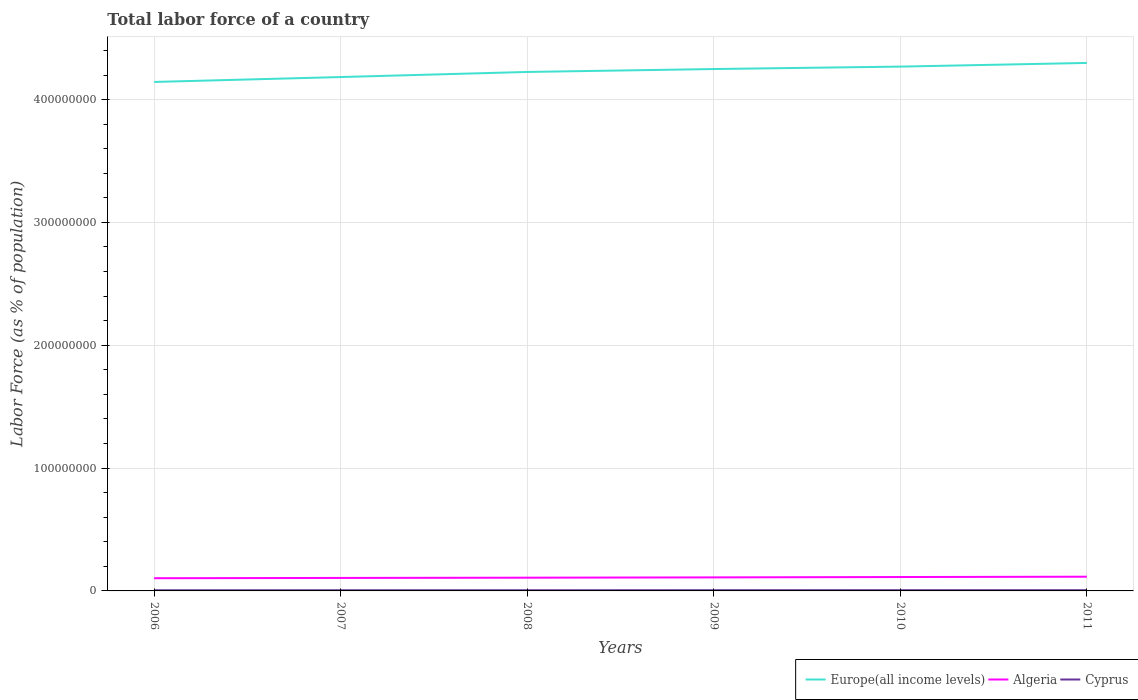How many different coloured lines are there?
Make the answer very short. 3. Is the number of lines equal to the number of legend labels?
Offer a terse response. Yes. Across all years, what is the maximum percentage of labor force in Cyprus?
Ensure brevity in your answer.  5.37e+05. In which year was the percentage of labor force in Europe(all income levels) maximum?
Offer a terse response. 2006. What is the total percentage of labor force in Algeria in the graph?
Give a very brief answer. -2.43e+05. What is the difference between the highest and the second highest percentage of labor force in Cyprus?
Your answer should be very brief. 4.87e+04. What is the difference between the highest and the lowest percentage of labor force in Algeria?
Make the answer very short. 3. Is the percentage of labor force in Europe(all income levels) strictly greater than the percentage of labor force in Cyprus over the years?
Your answer should be very brief. No. How many lines are there?
Offer a very short reply. 3. What is the difference between two consecutive major ticks on the Y-axis?
Make the answer very short. 1.00e+08. Are the values on the major ticks of Y-axis written in scientific E-notation?
Your answer should be very brief. No. Does the graph contain any zero values?
Your answer should be very brief. No. Does the graph contain grids?
Make the answer very short. Yes. How many legend labels are there?
Provide a succinct answer. 3. How are the legend labels stacked?
Your response must be concise. Horizontal. What is the title of the graph?
Ensure brevity in your answer.  Total labor force of a country. What is the label or title of the Y-axis?
Offer a terse response. Labor Force (as % of population). What is the Labor Force (as % of population) in Europe(all income levels) in 2006?
Your answer should be compact. 4.14e+08. What is the Labor Force (as % of population) in Algeria in 2006?
Keep it short and to the point. 1.03e+07. What is the Labor Force (as % of population) in Cyprus in 2006?
Offer a very short reply. 5.37e+05. What is the Labor Force (as % of population) in Europe(all income levels) in 2007?
Your answer should be very brief. 4.18e+08. What is the Labor Force (as % of population) of Algeria in 2007?
Offer a very short reply. 1.06e+07. What is the Labor Force (as % of population) of Cyprus in 2007?
Ensure brevity in your answer.  5.50e+05. What is the Labor Force (as % of population) of Europe(all income levels) in 2008?
Make the answer very short. 4.22e+08. What is the Labor Force (as % of population) in Algeria in 2008?
Provide a short and direct response. 1.08e+07. What is the Labor Force (as % of population) of Cyprus in 2008?
Give a very brief answer. 5.60e+05. What is the Labor Force (as % of population) of Europe(all income levels) in 2009?
Provide a succinct answer. 4.25e+08. What is the Labor Force (as % of population) in Algeria in 2009?
Make the answer very short. 1.10e+07. What is the Labor Force (as % of population) of Cyprus in 2009?
Give a very brief answer. 5.71e+05. What is the Labor Force (as % of population) of Europe(all income levels) in 2010?
Your response must be concise. 4.27e+08. What is the Labor Force (as % of population) in Algeria in 2010?
Offer a very short reply. 1.13e+07. What is the Labor Force (as % of population) of Cyprus in 2010?
Provide a succinct answer. 5.84e+05. What is the Labor Force (as % of population) of Europe(all income levels) in 2011?
Provide a short and direct response. 4.30e+08. What is the Labor Force (as % of population) in Algeria in 2011?
Your answer should be very brief. 1.16e+07. What is the Labor Force (as % of population) in Cyprus in 2011?
Your response must be concise. 5.86e+05. Across all years, what is the maximum Labor Force (as % of population) of Europe(all income levels)?
Give a very brief answer. 4.30e+08. Across all years, what is the maximum Labor Force (as % of population) in Algeria?
Provide a succinct answer. 1.16e+07. Across all years, what is the maximum Labor Force (as % of population) of Cyprus?
Your answer should be compact. 5.86e+05. Across all years, what is the minimum Labor Force (as % of population) in Europe(all income levels)?
Ensure brevity in your answer.  4.14e+08. Across all years, what is the minimum Labor Force (as % of population) of Algeria?
Provide a short and direct response. 1.03e+07. Across all years, what is the minimum Labor Force (as % of population) of Cyprus?
Your answer should be very brief. 5.37e+05. What is the total Labor Force (as % of population) of Europe(all income levels) in the graph?
Your response must be concise. 2.54e+09. What is the total Labor Force (as % of population) in Algeria in the graph?
Give a very brief answer. 6.56e+07. What is the total Labor Force (as % of population) in Cyprus in the graph?
Your answer should be very brief. 3.39e+06. What is the difference between the Labor Force (as % of population) in Europe(all income levels) in 2006 and that in 2007?
Keep it short and to the point. -3.99e+06. What is the difference between the Labor Force (as % of population) in Algeria in 2006 and that in 2007?
Keep it short and to the point. -2.33e+05. What is the difference between the Labor Force (as % of population) of Cyprus in 2006 and that in 2007?
Offer a very short reply. -1.30e+04. What is the difference between the Labor Force (as % of population) in Europe(all income levels) in 2006 and that in 2008?
Your response must be concise. -8.14e+06. What is the difference between the Labor Force (as % of population) in Algeria in 2006 and that in 2008?
Keep it short and to the point. -4.32e+05. What is the difference between the Labor Force (as % of population) of Cyprus in 2006 and that in 2008?
Offer a terse response. -2.25e+04. What is the difference between the Labor Force (as % of population) in Europe(all income levels) in 2006 and that in 2009?
Your response must be concise. -1.05e+07. What is the difference between the Labor Force (as % of population) of Algeria in 2006 and that in 2009?
Offer a terse response. -6.75e+05. What is the difference between the Labor Force (as % of population) in Cyprus in 2006 and that in 2009?
Provide a succinct answer. -3.36e+04. What is the difference between the Labor Force (as % of population) of Europe(all income levels) in 2006 and that in 2010?
Make the answer very short. -1.25e+07. What is the difference between the Labor Force (as % of population) of Algeria in 2006 and that in 2010?
Keep it short and to the point. -9.66e+05. What is the difference between the Labor Force (as % of population) in Cyprus in 2006 and that in 2010?
Make the answer very short. -4.73e+04. What is the difference between the Labor Force (as % of population) in Europe(all income levels) in 2006 and that in 2011?
Offer a very short reply. -1.55e+07. What is the difference between the Labor Force (as % of population) of Algeria in 2006 and that in 2011?
Offer a terse response. -1.23e+06. What is the difference between the Labor Force (as % of population) of Cyprus in 2006 and that in 2011?
Provide a succinct answer. -4.87e+04. What is the difference between the Labor Force (as % of population) of Europe(all income levels) in 2007 and that in 2008?
Offer a very short reply. -4.15e+06. What is the difference between the Labor Force (as % of population) of Algeria in 2007 and that in 2008?
Keep it short and to the point. -1.99e+05. What is the difference between the Labor Force (as % of population) in Cyprus in 2007 and that in 2008?
Provide a short and direct response. -9460. What is the difference between the Labor Force (as % of population) of Europe(all income levels) in 2007 and that in 2009?
Your answer should be very brief. -6.53e+06. What is the difference between the Labor Force (as % of population) of Algeria in 2007 and that in 2009?
Offer a very short reply. -4.42e+05. What is the difference between the Labor Force (as % of population) in Cyprus in 2007 and that in 2009?
Your response must be concise. -2.06e+04. What is the difference between the Labor Force (as % of population) in Europe(all income levels) in 2007 and that in 2010?
Your answer should be very brief. -8.50e+06. What is the difference between the Labor Force (as % of population) in Algeria in 2007 and that in 2010?
Make the answer very short. -7.33e+05. What is the difference between the Labor Force (as % of population) in Cyprus in 2007 and that in 2010?
Offer a very short reply. -3.43e+04. What is the difference between the Labor Force (as % of population) of Europe(all income levels) in 2007 and that in 2011?
Provide a succinct answer. -1.15e+07. What is the difference between the Labor Force (as % of population) of Algeria in 2007 and that in 2011?
Offer a very short reply. -9.94e+05. What is the difference between the Labor Force (as % of population) in Cyprus in 2007 and that in 2011?
Your answer should be very brief. -3.57e+04. What is the difference between the Labor Force (as % of population) of Europe(all income levels) in 2008 and that in 2009?
Offer a very short reply. -2.38e+06. What is the difference between the Labor Force (as % of population) in Algeria in 2008 and that in 2009?
Give a very brief answer. -2.43e+05. What is the difference between the Labor Force (as % of population) in Cyprus in 2008 and that in 2009?
Your answer should be very brief. -1.11e+04. What is the difference between the Labor Force (as % of population) of Europe(all income levels) in 2008 and that in 2010?
Give a very brief answer. -4.35e+06. What is the difference between the Labor Force (as % of population) of Algeria in 2008 and that in 2010?
Give a very brief answer. -5.34e+05. What is the difference between the Labor Force (as % of population) of Cyprus in 2008 and that in 2010?
Offer a terse response. -2.48e+04. What is the difference between the Labor Force (as % of population) of Europe(all income levels) in 2008 and that in 2011?
Your answer should be very brief. -7.33e+06. What is the difference between the Labor Force (as % of population) in Algeria in 2008 and that in 2011?
Give a very brief answer. -7.95e+05. What is the difference between the Labor Force (as % of population) of Cyprus in 2008 and that in 2011?
Ensure brevity in your answer.  -2.62e+04. What is the difference between the Labor Force (as % of population) in Europe(all income levels) in 2009 and that in 2010?
Offer a very short reply. -1.97e+06. What is the difference between the Labor Force (as % of population) in Algeria in 2009 and that in 2010?
Offer a very short reply. -2.91e+05. What is the difference between the Labor Force (as % of population) of Cyprus in 2009 and that in 2010?
Keep it short and to the point. -1.37e+04. What is the difference between the Labor Force (as % of population) of Europe(all income levels) in 2009 and that in 2011?
Provide a succinct answer. -4.95e+06. What is the difference between the Labor Force (as % of population) of Algeria in 2009 and that in 2011?
Provide a short and direct response. -5.52e+05. What is the difference between the Labor Force (as % of population) in Cyprus in 2009 and that in 2011?
Provide a succinct answer. -1.51e+04. What is the difference between the Labor Force (as % of population) of Europe(all income levels) in 2010 and that in 2011?
Provide a succinct answer. -2.99e+06. What is the difference between the Labor Force (as % of population) of Algeria in 2010 and that in 2011?
Provide a succinct answer. -2.61e+05. What is the difference between the Labor Force (as % of population) in Cyprus in 2010 and that in 2011?
Your answer should be compact. -1364. What is the difference between the Labor Force (as % of population) in Europe(all income levels) in 2006 and the Labor Force (as % of population) in Algeria in 2007?
Your answer should be compact. 4.04e+08. What is the difference between the Labor Force (as % of population) of Europe(all income levels) in 2006 and the Labor Force (as % of population) of Cyprus in 2007?
Keep it short and to the point. 4.14e+08. What is the difference between the Labor Force (as % of population) in Algeria in 2006 and the Labor Force (as % of population) in Cyprus in 2007?
Provide a succinct answer. 9.79e+06. What is the difference between the Labor Force (as % of population) of Europe(all income levels) in 2006 and the Labor Force (as % of population) of Algeria in 2008?
Offer a very short reply. 4.04e+08. What is the difference between the Labor Force (as % of population) of Europe(all income levels) in 2006 and the Labor Force (as % of population) of Cyprus in 2008?
Keep it short and to the point. 4.14e+08. What is the difference between the Labor Force (as % of population) in Algeria in 2006 and the Labor Force (as % of population) in Cyprus in 2008?
Provide a short and direct response. 9.78e+06. What is the difference between the Labor Force (as % of population) in Europe(all income levels) in 2006 and the Labor Force (as % of population) in Algeria in 2009?
Your answer should be compact. 4.03e+08. What is the difference between the Labor Force (as % of population) in Europe(all income levels) in 2006 and the Labor Force (as % of population) in Cyprus in 2009?
Offer a very short reply. 4.14e+08. What is the difference between the Labor Force (as % of population) in Algeria in 2006 and the Labor Force (as % of population) in Cyprus in 2009?
Provide a short and direct response. 9.77e+06. What is the difference between the Labor Force (as % of population) of Europe(all income levels) in 2006 and the Labor Force (as % of population) of Algeria in 2010?
Offer a terse response. 4.03e+08. What is the difference between the Labor Force (as % of population) of Europe(all income levels) in 2006 and the Labor Force (as % of population) of Cyprus in 2010?
Offer a very short reply. 4.14e+08. What is the difference between the Labor Force (as % of population) in Algeria in 2006 and the Labor Force (as % of population) in Cyprus in 2010?
Offer a terse response. 9.76e+06. What is the difference between the Labor Force (as % of population) in Europe(all income levels) in 2006 and the Labor Force (as % of population) in Algeria in 2011?
Make the answer very short. 4.03e+08. What is the difference between the Labor Force (as % of population) of Europe(all income levels) in 2006 and the Labor Force (as % of population) of Cyprus in 2011?
Give a very brief answer. 4.14e+08. What is the difference between the Labor Force (as % of population) in Algeria in 2006 and the Labor Force (as % of population) in Cyprus in 2011?
Keep it short and to the point. 9.76e+06. What is the difference between the Labor Force (as % of population) of Europe(all income levels) in 2007 and the Labor Force (as % of population) of Algeria in 2008?
Your answer should be very brief. 4.08e+08. What is the difference between the Labor Force (as % of population) of Europe(all income levels) in 2007 and the Labor Force (as % of population) of Cyprus in 2008?
Offer a terse response. 4.18e+08. What is the difference between the Labor Force (as % of population) in Algeria in 2007 and the Labor Force (as % of population) in Cyprus in 2008?
Your answer should be compact. 1.00e+07. What is the difference between the Labor Force (as % of population) in Europe(all income levels) in 2007 and the Labor Force (as % of population) in Algeria in 2009?
Make the answer very short. 4.07e+08. What is the difference between the Labor Force (as % of population) in Europe(all income levels) in 2007 and the Labor Force (as % of population) in Cyprus in 2009?
Provide a succinct answer. 4.18e+08. What is the difference between the Labor Force (as % of population) of Algeria in 2007 and the Labor Force (as % of population) of Cyprus in 2009?
Provide a succinct answer. 1.00e+07. What is the difference between the Labor Force (as % of population) of Europe(all income levels) in 2007 and the Labor Force (as % of population) of Algeria in 2010?
Offer a very short reply. 4.07e+08. What is the difference between the Labor Force (as % of population) of Europe(all income levels) in 2007 and the Labor Force (as % of population) of Cyprus in 2010?
Provide a succinct answer. 4.18e+08. What is the difference between the Labor Force (as % of population) of Algeria in 2007 and the Labor Force (as % of population) of Cyprus in 2010?
Give a very brief answer. 9.99e+06. What is the difference between the Labor Force (as % of population) in Europe(all income levels) in 2007 and the Labor Force (as % of population) in Algeria in 2011?
Your answer should be very brief. 4.07e+08. What is the difference between the Labor Force (as % of population) of Europe(all income levels) in 2007 and the Labor Force (as % of population) of Cyprus in 2011?
Make the answer very short. 4.18e+08. What is the difference between the Labor Force (as % of population) in Algeria in 2007 and the Labor Force (as % of population) in Cyprus in 2011?
Your response must be concise. 9.99e+06. What is the difference between the Labor Force (as % of population) in Europe(all income levels) in 2008 and the Labor Force (as % of population) in Algeria in 2009?
Ensure brevity in your answer.  4.11e+08. What is the difference between the Labor Force (as % of population) of Europe(all income levels) in 2008 and the Labor Force (as % of population) of Cyprus in 2009?
Provide a short and direct response. 4.22e+08. What is the difference between the Labor Force (as % of population) in Algeria in 2008 and the Labor Force (as % of population) in Cyprus in 2009?
Offer a terse response. 1.02e+07. What is the difference between the Labor Force (as % of population) of Europe(all income levels) in 2008 and the Labor Force (as % of population) of Algeria in 2010?
Offer a terse response. 4.11e+08. What is the difference between the Labor Force (as % of population) of Europe(all income levels) in 2008 and the Labor Force (as % of population) of Cyprus in 2010?
Provide a short and direct response. 4.22e+08. What is the difference between the Labor Force (as % of population) of Algeria in 2008 and the Labor Force (as % of population) of Cyprus in 2010?
Your answer should be very brief. 1.02e+07. What is the difference between the Labor Force (as % of population) of Europe(all income levels) in 2008 and the Labor Force (as % of population) of Algeria in 2011?
Your answer should be compact. 4.11e+08. What is the difference between the Labor Force (as % of population) in Europe(all income levels) in 2008 and the Labor Force (as % of population) in Cyprus in 2011?
Your answer should be compact. 4.22e+08. What is the difference between the Labor Force (as % of population) of Algeria in 2008 and the Labor Force (as % of population) of Cyprus in 2011?
Your answer should be compact. 1.02e+07. What is the difference between the Labor Force (as % of population) in Europe(all income levels) in 2009 and the Labor Force (as % of population) in Algeria in 2010?
Ensure brevity in your answer.  4.14e+08. What is the difference between the Labor Force (as % of population) of Europe(all income levels) in 2009 and the Labor Force (as % of population) of Cyprus in 2010?
Make the answer very short. 4.24e+08. What is the difference between the Labor Force (as % of population) in Algeria in 2009 and the Labor Force (as % of population) in Cyprus in 2010?
Offer a terse response. 1.04e+07. What is the difference between the Labor Force (as % of population) in Europe(all income levels) in 2009 and the Labor Force (as % of population) in Algeria in 2011?
Your answer should be compact. 4.13e+08. What is the difference between the Labor Force (as % of population) of Europe(all income levels) in 2009 and the Labor Force (as % of population) of Cyprus in 2011?
Ensure brevity in your answer.  4.24e+08. What is the difference between the Labor Force (as % of population) of Algeria in 2009 and the Labor Force (as % of population) of Cyprus in 2011?
Your response must be concise. 1.04e+07. What is the difference between the Labor Force (as % of population) of Europe(all income levels) in 2010 and the Labor Force (as % of population) of Algeria in 2011?
Keep it short and to the point. 4.15e+08. What is the difference between the Labor Force (as % of population) in Europe(all income levels) in 2010 and the Labor Force (as % of population) in Cyprus in 2011?
Provide a short and direct response. 4.26e+08. What is the difference between the Labor Force (as % of population) in Algeria in 2010 and the Labor Force (as % of population) in Cyprus in 2011?
Your answer should be very brief. 1.07e+07. What is the average Labor Force (as % of population) in Europe(all income levels) per year?
Offer a terse response. 4.23e+08. What is the average Labor Force (as % of population) in Algeria per year?
Make the answer very short. 1.09e+07. What is the average Labor Force (as % of population) of Cyprus per year?
Provide a succinct answer. 5.65e+05. In the year 2006, what is the difference between the Labor Force (as % of population) of Europe(all income levels) and Labor Force (as % of population) of Algeria?
Your answer should be compact. 4.04e+08. In the year 2006, what is the difference between the Labor Force (as % of population) of Europe(all income levels) and Labor Force (as % of population) of Cyprus?
Make the answer very short. 4.14e+08. In the year 2006, what is the difference between the Labor Force (as % of population) of Algeria and Labor Force (as % of population) of Cyprus?
Ensure brevity in your answer.  9.81e+06. In the year 2007, what is the difference between the Labor Force (as % of population) of Europe(all income levels) and Labor Force (as % of population) of Algeria?
Your answer should be very brief. 4.08e+08. In the year 2007, what is the difference between the Labor Force (as % of population) of Europe(all income levels) and Labor Force (as % of population) of Cyprus?
Offer a very short reply. 4.18e+08. In the year 2007, what is the difference between the Labor Force (as % of population) of Algeria and Labor Force (as % of population) of Cyprus?
Give a very brief answer. 1.00e+07. In the year 2008, what is the difference between the Labor Force (as % of population) in Europe(all income levels) and Labor Force (as % of population) in Algeria?
Ensure brevity in your answer.  4.12e+08. In the year 2008, what is the difference between the Labor Force (as % of population) in Europe(all income levels) and Labor Force (as % of population) in Cyprus?
Provide a succinct answer. 4.22e+08. In the year 2008, what is the difference between the Labor Force (as % of population) of Algeria and Labor Force (as % of population) of Cyprus?
Offer a very short reply. 1.02e+07. In the year 2009, what is the difference between the Labor Force (as % of population) of Europe(all income levels) and Labor Force (as % of population) of Algeria?
Your answer should be very brief. 4.14e+08. In the year 2009, what is the difference between the Labor Force (as % of population) of Europe(all income levels) and Labor Force (as % of population) of Cyprus?
Provide a short and direct response. 4.24e+08. In the year 2009, what is the difference between the Labor Force (as % of population) of Algeria and Labor Force (as % of population) of Cyprus?
Ensure brevity in your answer.  1.04e+07. In the year 2010, what is the difference between the Labor Force (as % of population) of Europe(all income levels) and Labor Force (as % of population) of Algeria?
Provide a short and direct response. 4.16e+08. In the year 2010, what is the difference between the Labor Force (as % of population) in Europe(all income levels) and Labor Force (as % of population) in Cyprus?
Give a very brief answer. 4.26e+08. In the year 2010, what is the difference between the Labor Force (as % of population) of Algeria and Labor Force (as % of population) of Cyprus?
Provide a short and direct response. 1.07e+07. In the year 2011, what is the difference between the Labor Force (as % of population) of Europe(all income levels) and Labor Force (as % of population) of Algeria?
Keep it short and to the point. 4.18e+08. In the year 2011, what is the difference between the Labor Force (as % of population) of Europe(all income levels) and Labor Force (as % of population) of Cyprus?
Give a very brief answer. 4.29e+08. In the year 2011, what is the difference between the Labor Force (as % of population) in Algeria and Labor Force (as % of population) in Cyprus?
Your response must be concise. 1.10e+07. What is the ratio of the Labor Force (as % of population) of Cyprus in 2006 to that in 2007?
Ensure brevity in your answer.  0.98. What is the ratio of the Labor Force (as % of population) of Europe(all income levels) in 2006 to that in 2008?
Your answer should be very brief. 0.98. What is the ratio of the Labor Force (as % of population) of Algeria in 2006 to that in 2008?
Ensure brevity in your answer.  0.96. What is the ratio of the Labor Force (as % of population) in Cyprus in 2006 to that in 2008?
Provide a short and direct response. 0.96. What is the ratio of the Labor Force (as % of population) in Europe(all income levels) in 2006 to that in 2009?
Your answer should be very brief. 0.98. What is the ratio of the Labor Force (as % of population) of Algeria in 2006 to that in 2009?
Offer a terse response. 0.94. What is the ratio of the Labor Force (as % of population) in Cyprus in 2006 to that in 2009?
Give a very brief answer. 0.94. What is the ratio of the Labor Force (as % of population) in Europe(all income levels) in 2006 to that in 2010?
Your answer should be very brief. 0.97. What is the ratio of the Labor Force (as % of population) of Algeria in 2006 to that in 2010?
Keep it short and to the point. 0.91. What is the ratio of the Labor Force (as % of population) of Cyprus in 2006 to that in 2010?
Your answer should be compact. 0.92. What is the ratio of the Labor Force (as % of population) in Europe(all income levels) in 2006 to that in 2011?
Offer a very short reply. 0.96. What is the ratio of the Labor Force (as % of population) in Algeria in 2006 to that in 2011?
Ensure brevity in your answer.  0.89. What is the ratio of the Labor Force (as % of population) of Cyprus in 2006 to that in 2011?
Offer a terse response. 0.92. What is the ratio of the Labor Force (as % of population) in Europe(all income levels) in 2007 to that in 2008?
Keep it short and to the point. 0.99. What is the ratio of the Labor Force (as % of population) in Algeria in 2007 to that in 2008?
Provide a succinct answer. 0.98. What is the ratio of the Labor Force (as % of population) in Cyprus in 2007 to that in 2008?
Ensure brevity in your answer.  0.98. What is the ratio of the Labor Force (as % of population) of Europe(all income levels) in 2007 to that in 2009?
Your answer should be compact. 0.98. What is the ratio of the Labor Force (as % of population) of Algeria in 2007 to that in 2009?
Ensure brevity in your answer.  0.96. What is the ratio of the Labor Force (as % of population) of Europe(all income levels) in 2007 to that in 2010?
Offer a very short reply. 0.98. What is the ratio of the Labor Force (as % of population) in Algeria in 2007 to that in 2010?
Your answer should be very brief. 0.94. What is the ratio of the Labor Force (as % of population) in Cyprus in 2007 to that in 2010?
Offer a terse response. 0.94. What is the ratio of the Labor Force (as % of population) in Europe(all income levels) in 2007 to that in 2011?
Offer a very short reply. 0.97. What is the ratio of the Labor Force (as % of population) in Algeria in 2007 to that in 2011?
Give a very brief answer. 0.91. What is the ratio of the Labor Force (as % of population) of Cyprus in 2007 to that in 2011?
Keep it short and to the point. 0.94. What is the ratio of the Labor Force (as % of population) of Algeria in 2008 to that in 2009?
Offer a very short reply. 0.98. What is the ratio of the Labor Force (as % of population) in Cyprus in 2008 to that in 2009?
Ensure brevity in your answer.  0.98. What is the ratio of the Labor Force (as % of population) in Europe(all income levels) in 2008 to that in 2010?
Provide a short and direct response. 0.99. What is the ratio of the Labor Force (as % of population) of Algeria in 2008 to that in 2010?
Make the answer very short. 0.95. What is the ratio of the Labor Force (as % of population) of Cyprus in 2008 to that in 2010?
Make the answer very short. 0.96. What is the ratio of the Labor Force (as % of population) of Europe(all income levels) in 2008 to that in 2011?
Your answer should be compact. 0.98. What is the ratio of the Labor Force (as % of population) of Algeria in 2008 to that in 2011?
Give a very brief answer. 0.93. What is the ratio of the Labor Force (as % of population) in Cyprus in 2008 to that in 2011?
Offer a terse response. 0.96. What is the ratio of the Labor Force (as % of population) in Europe(all income levels) in 2009 to that in 2010?
Your answer should be compact. 1. What is the ratio of the Labor Force (as % of population) of Algeria in 2009 to that in 2010?
Make the answer very short. 0.97. What is the ratio of the Labor Force (as % of population) of Cyprus in 2009 to that in 2010?
Offer a very short reply. 0.98. What is the ratio of the Labor Force (as % of population) of Europe(all income levels) in 2009 to that in 2011?
Make the answer very short. 0.99. What is the ratio of the Labor Force (as % of population) of Algeria in 2009 to that in 2011?
Provide a succinct answer. 0.95. What is the ratio of the Labor Force (as % of population) in Cyprus in 2009 to that in 2011?
Keep it short and to the point. 0.97. What is the ratio of the Labor Force (as % of population) in Europe(all income levels) in 2010 to that in 2011?
Your response must be concise. 0.99. What is the ratio of the Labor Force (as % of population) of Algeria in 2010 to that in 2011?
Your answer should be compact. 0.98. What is the ratio of the Labor Force (as % of population) in Cyprus in 2010 to that in 2011?
Provide a short and direct response. 1. What is the difference between the highest and the second highest Labor Force (as % of population) in Europe(all income levels)?
Offer a very short reply. 2.99e+06. What is the difference between the highest and the second highest Labor Force (as % of population) of Algeria?
Your answer should be very brief. 2.61e+05. What is the difference between the highest and the second highest Labor Force (as % of population) of Cyprus?
Keep it short and to the point. 1364. What is the difference between the highest and the lowest Labor Force (as % of population) of Europe(all income levels)?
Make the answer very short. 1.55e+07. What is the difference between the highest and the lowest Labor Force (as % of population) of Algeria?
Provide a succinct answer. 1.23e+06. What is the difference between the highest and the lowest Labor Force (as % of population) of Cyprus?
Your response must be concise. 4.87e+04. 